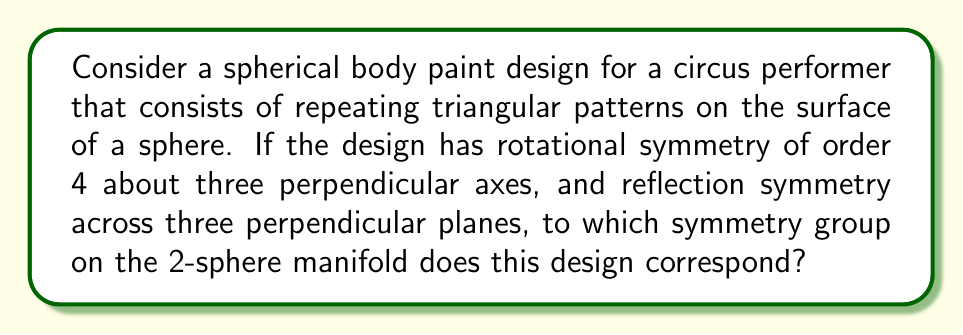Give your solution to this math problem. To solve this problem, we need to analyze the symmetries of the body paint design on the surface of a sphere (2-sphere manifold) using group theory. Let's approach this step-by-step:

1) First, we identify the symmetries described:
   - Rotational symmetry of order 4 about three perpendicular axes
   - Reflection symmetry across three perpendicular planes

2) These symmetries correspond to the following operations on the sphere:
   - 4-fold rotations around x, y, and z axes: $C_4^x$, $C_4^y$, $C_4^z$
   - Reflections in xy, yz, and xz planes: $\sigma_{xy}$, $\sigma_{yz}$, $\sigma_{xz}$

3) The combination of these symmetries generates additional symmetry elements:
   - 2-fold rotations about the same axes (by combining two 4-fold rotations)
   - 3-fold rotations about the body diagonals (by combining rotations about different axes)
   - 2-fold rotations about the face diagonals

4) Counting the symmetry operations:
   - Identity: 1
   - 4-fold rotations: 6 (±90° about each axis)
   - 3-fold rotations: 8 (±120° about body diagonals)
   - 2-fold rotations: 9 (180° about face diagonals and axes)
   - Reflections: 9 (3 planes and 6 diagonal planes)

5) The total number of symmetry operations is 1 + 6 + 8 + 9 + 9 = 33

6) This collection of symmetries forms a group on the 2-sphere manifold. The group with these properties is known as the octahedral group, also denoted as $O_h$ in Schönflies notation or $m\bar{3}m$ in Hermann–Mauguin notation.

7) The octahedral group is isomorphic to the direct product of the rotation group of a cube (or octahedron) and the group $\{1, -1\}$ under multiplication, which adds the reflection symmetries.

Therefore, the symmetry group on the 2-sphere manifold that corresponds to this body paint design is the full octahedral group.
Answer: The octahedral group ($O_h$) 